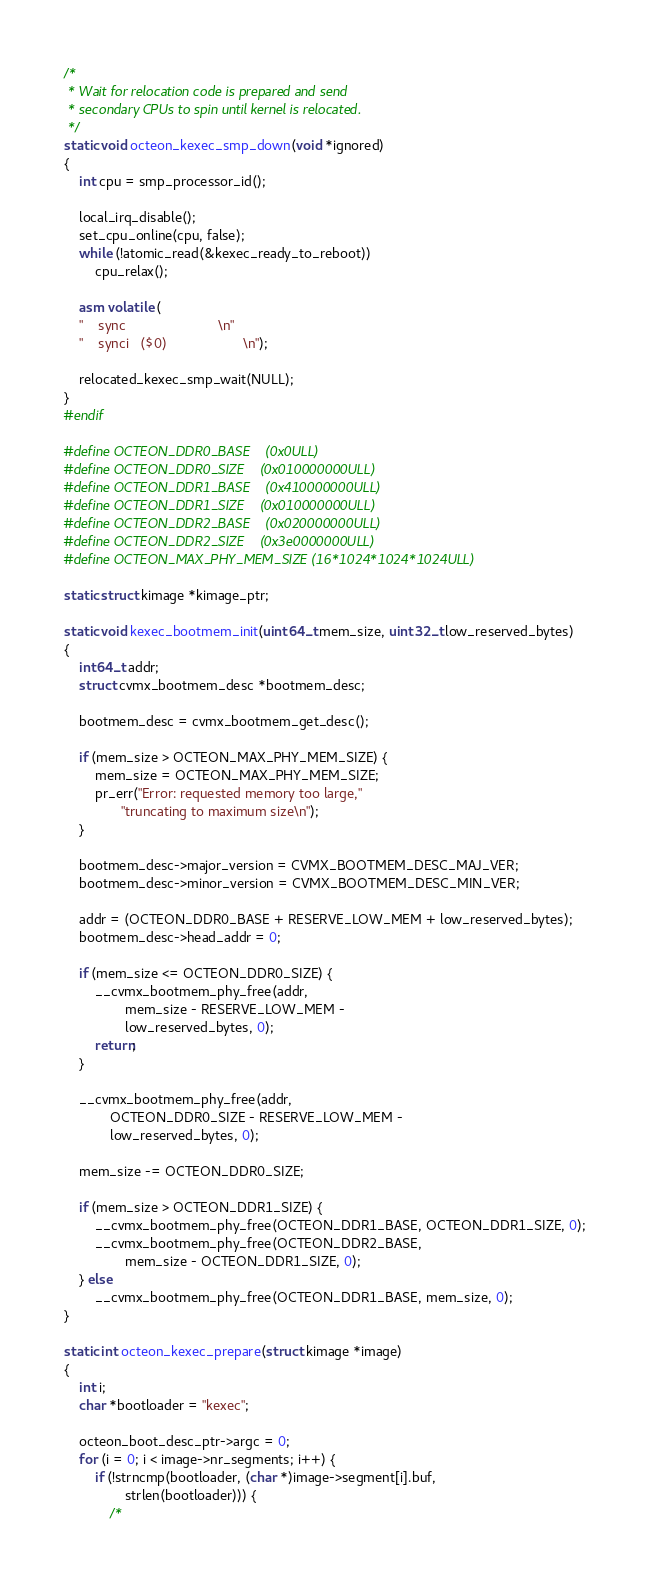Convert code to text. <code><loc_0><loc_0><loc_500><loc_500><_C_>/*
 * Wait for relocation code is prepared and send
 * secondary CPUs to spin until kernel is relocated.
 */
static void octeon_kexec_smp_down(void *ignored)
{
	int cpu = smp_processor_id();

	local_irq_disable();
	set_cpu_online(cpu, false);
	while (!atomic_read(&kexec_ready_to_reboot))
		cpu_relax();

	asm volatile (
	"	sync						\n"
	"	synci	($0)					\n");

	relocated_kexec_smp_wait(NULL);
}
#endif

#define OCTEON_DDR0_BASE    (0x0ULL)
#define OCTEON_DDR0_SIZE    (0x010000000ULL)
#define OCTEON_DDR1_BASE    (0x410000000ULL)
#define OCTEON_DDR1_SIZE    (0x010000000ULL)
#define OCTEON_DDR2_BASE    (0x020000000ULL)
#define OCTEON_DDR2_SIZE    (0x3e0000000ULL)
#define OCTEON_MAX_PHY_MEM_SIZE (16*1024*1024*1024ULL)

static struct kimage *kimage_ptr;

static void kexec_bootmem_init(uint64_t mem_size, uint32_t low_reserved_bytes)
{
	int64_t addr;
	struct cvmx_bootmem_desc *bootmem_desc;

	bootmem_desc = cvmx_bootmem_get_desc();

	if (mem_size > OCTEON_MAX_PHY_MEM_SIZE) {
		mem_size = OCTEON_MAX_PHY_MEM_SIZE;
		pr_err("Error: requested memory too large,"
		       "truncating to maximum size\n");
	}

	bootmem_desc->major_version = CVMX_BOOTMEM_DESC_MAJ_VER;
	bootmem_desc->minor_version = CVMX_BOOTMEM_DESC_MIN_VER;

	addr = (OCTEON_DDR0_BASE + RESERVE_LOW_MEM + low_reserved_bytes);
	bootmem_desc->head_addr = 0;

	if (mem_size <= OCTEON_DDR0_SIZE) {
		__cvmx_bootmem_phy_free(addr,
				mem_size - RESERVE_LOW_MEM -
				low_reserved_bytes, 0);
		return;
	}

	__cvmx_bootmem_phy_free(addr,
			OCTEON_DDR0_SIZE - RESERVE_LOW_MEM -
			low_reserved_bytes, 0);

	mem_size -= OCTEON_DDR0_SIZE;

	if (mem_size > OCTEON_DDR1_SIZE) {
		__cvmx_bootmem_phy_free(OCTEON_DDR1_BASE, OCTEON_DDR1_SIZE, 0);
		__cvmx_bootmem_phy_free(OCTEON_DDR2_BASE,
				mem_size - OCTEON_DDR1_SIZE, 0);
	} else
		__cvmx_bootmem_phy_free(OCTEON_DDR1_BASE, mem_size, 0);
}

static int octeon_kexec_prepare(struct kimage *image)
{
	int i;
	char *bootloader = "kexec";

	octeon_boot_desc_ptr->argc = 0;
	for (i = 0; i < image->nr_segments; i++) {
		if (!strncmp(bootloader, (char *)image->segment[i].buf,
				strlen(bootloader))) {
			/*</code> 